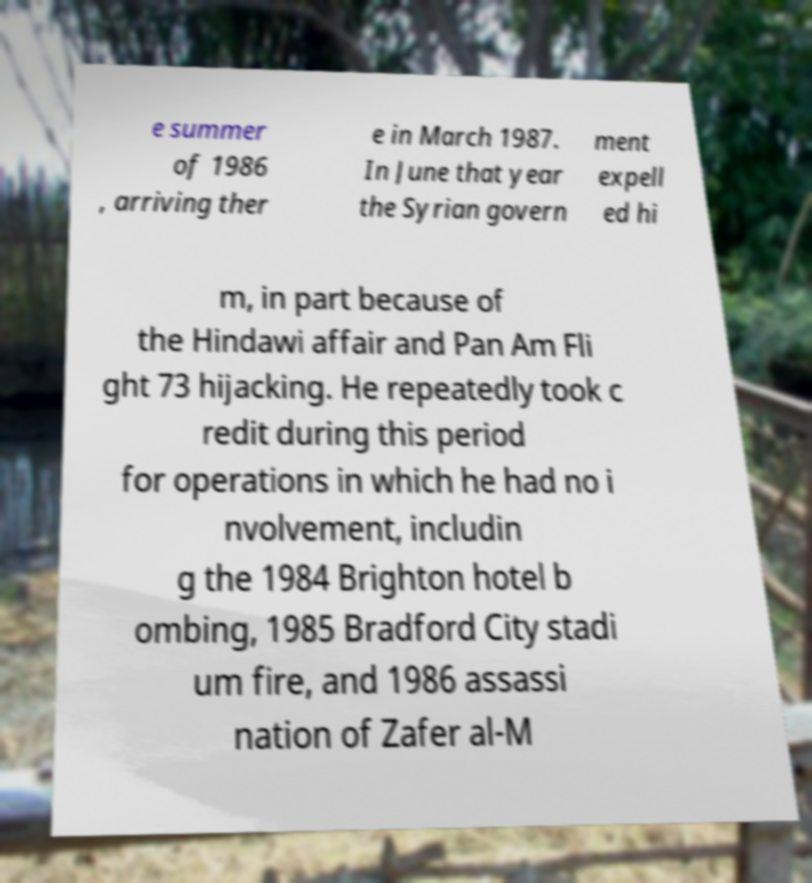There's text embedded in this image that I need extracted. Can you transcribe it verbatim? e summer of 1986 , arriving ther e in March 1987. In June that year the Syrian govern ment expell ed hi m, in part because of the Hindawi affair and Pan Am Fli ght 73 hijacking. He repeatedly took c redit during this period for operations in which he had no i nvolvement, includin g the 1984 Brighton hotel b ombing, 1985 Bradford City stadi um fire, and 1986 assassi nation of Zafer al-M 